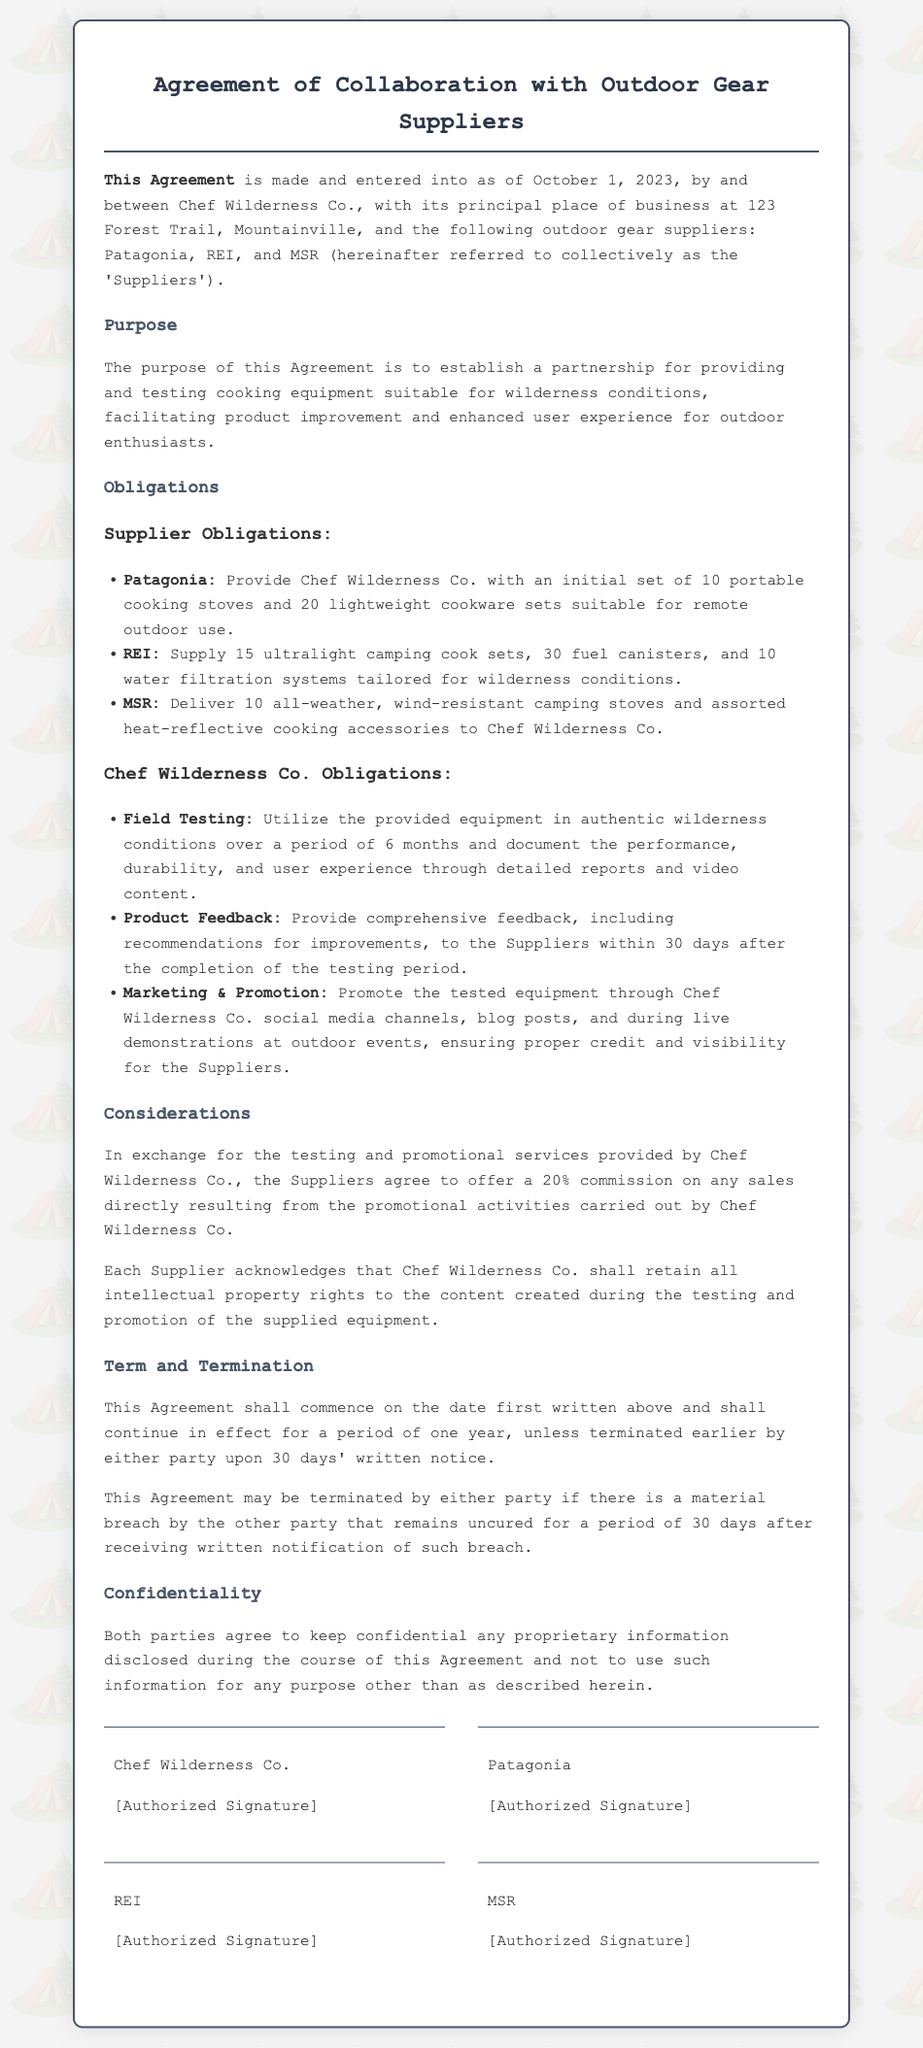What is the date of the agreement? The date of the agreement is stated at the beginning of the document.
Answer: October 1, 2023 Who are the outdoor gear suppliers mentioned? The suppliers listed in the document are specifically named in the introduction.
Answer: Patagonia, REI, MSR How many portable cooking stoves will Patagonia provide? The number of stoves Patagonia is obligated to provide is mentioned in the obligations section.
Answer: 10 What is the commission percentage agreed upon for sales? The commission percent for sales is detailed under the considerations section.
Answer: 20% What is the duration of the agreement? The duration of the agreement is stated in the term and termination section.
Answer: One year What is required from Chef Wilderness Co. within 30 days after testing? The obligations of Chef Wilderness Co. regarding the feedback timeframe are outlined in the document.
Answer: Comprehensive feedback How many fuel canisters will REI supply? The number of fuel canisters REI is obligated to provide is specified in the obligations section.
Answer: 30 What kind of confidentiality is mentioned in the agreement? The type of confidentiality both parties agree to is described in the confidentiality section.
Answer: Proprietary information 